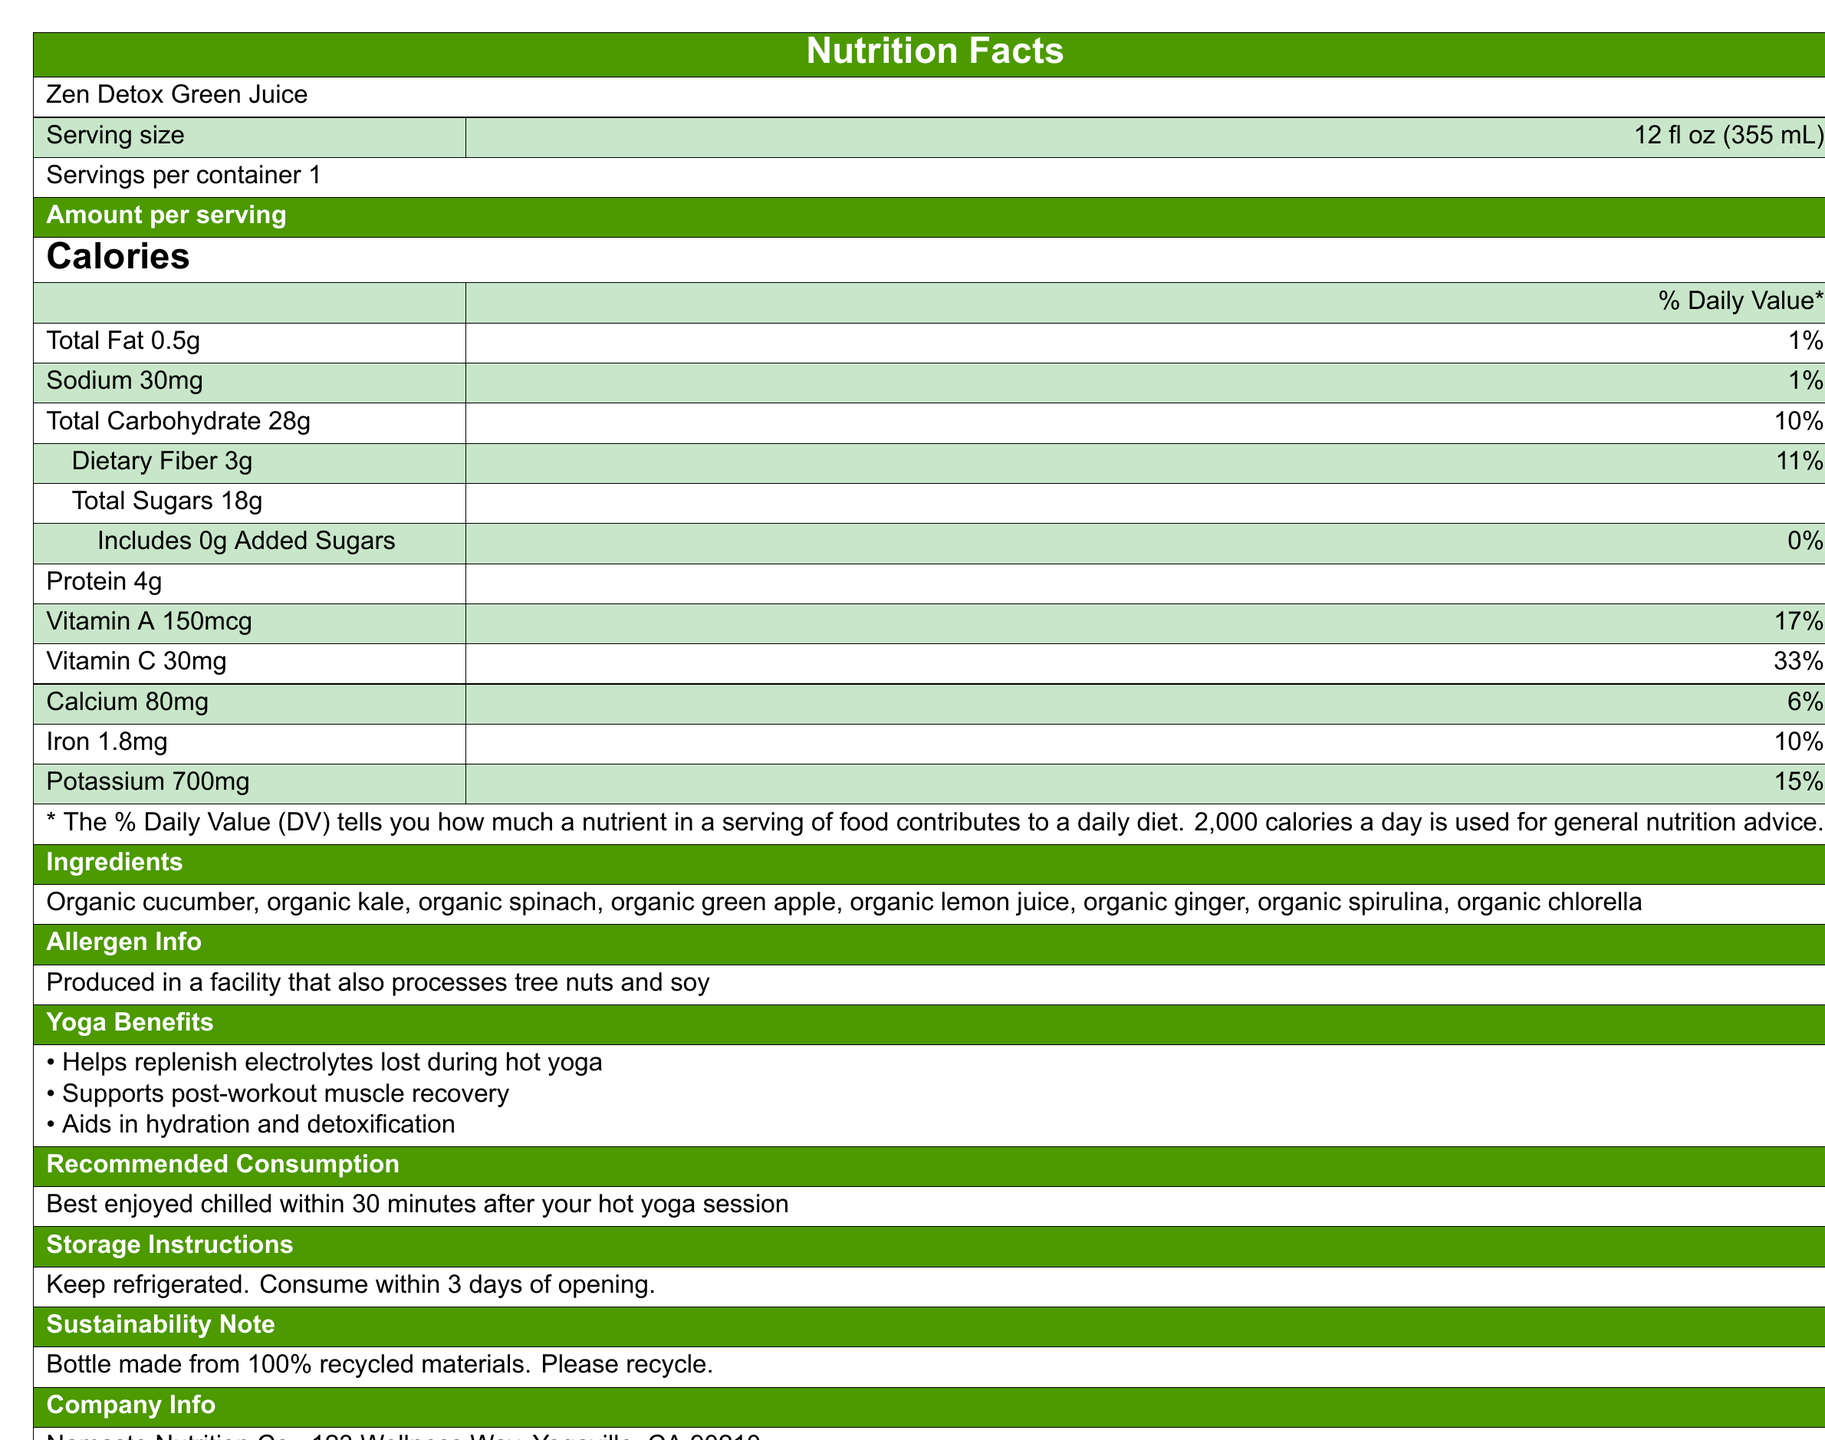what is the serving size for Zen Detox Green Juice? The document lists the serving size as "12 fl oz (355 mL)" under the product name.
Answer: 12 fl oz (355 mL) how many calories are in a serving of Zen Detox Green Juice? The number of calories per serving is prominently displayed as 120.
Answer: 120 what is the amount of dietary fiber in one serving, and its % Daily Value? The document specifies dietary fiber as 3g, which is 11% of the Daily Value.
Answer: 3g, 11% which vitamins are highlighted as being in significant amounts, and what are their % Daily Values? The vitamins provided in significant amounts are Vitamin A at 17% of the Daily Value and Vitamin C at 33%.
Answer: Vitamin A: 17%, Vitamin C: 33% what is the Total Fat content and its % Daily Value in the drink? The Total Fat content is 0.5g, which accounts for 1% of the Daily Value.
Answer: 0.5g, 1% what ingredients are included in the Zen Detox Green Juice? The ingredients are listed as organic cucumber, kale, spinach, green apple, lemon juice, ginger, spirulina, and chlorella.
Answer: Organic cucumber, Organic kale, Organic spinach, Organic green apple, Organic lemon juice, Organic ginger, Organic spirulina, Organic chlorella what is the sodium content per serving? The sodium content per serving is listed as 30mg.
Answer: 30mg what is the main claim regarding potassium content in Zen Detox Green Juice? A. Excellent source of potassium B. Good source of potassium C. Low source of potassium The health claims section mentions that Zen Detox Green Juice is a good source of potassium.
Answer: B. Good source of potassium which of the following is NOT an ingredient in Zen Detox Green Juice? A. Organic kale B. Organic green apple C. Organic carrot The ingredient list does not include organic carrot, while both organic kale and organic green apple are included.
Answer: C. Organic carrot is there any added sugar in Zen Detox Green Juice? The document states that the juice includes 0g of added sugars.
Answer: No is Zen Detox Green Juice suitable for someone with a tree nut allergy based on the allergen information provided? The allergen info reveals it is produced in a facility that also processes tree nuts, which might be problematic for someone with a tree nut allergy.
Answer: No what are the main benefits of this juice for yoga practitioners? The yoga benefits section lists these three main benefits specifically for yoga practitioners.
Answer: Helps replenish electrolytes, supports post-workout muscle recovery, aids in hydration and detoxification what is the best time to consume the juice after a hot yoga session for optimal benefits? The recommended consumption is to enjoy the juice chilled within 30 minutes after a hot yoga session.
Answer: Within 30 minutes how should the juice be stored and how long is it safe to consume after opening? The storage instructions clearly state to keep the juice refrigerated and consume it within 3 days of opening.
Answer: Keep refrigerated, consume within 3 days of opening. what sustainability practice is highlighted in the document? The document mentions that the bottle is made from 100% recycled materials and encourages recycling.
Answer: Bottle made from 100% recycled materials who is the manufacturer of Zen Detox Green Juice and where are they located? The company info states Namaste Nutrition Co. as the manufacturer located at 123 Wellness Way, Yogaville, CA 90210.
Answer: Namaste Nutrition Co., Yogaville, CA 90210 summarize the main idea of the document. The document details Zen Detox Green Juice's nutritional content, post-yoga benefits, ingredient list, storage instructions, sustainability practices, and allergen info.
Answer: The document provides detailed nutritional information about Zen Detox Green Juice, highlighting its benefits, ingredients, and storage instructions. It emphasizes the juice's suitability for post-hot yoga recovery, noting its nutritional benefits, including essential vitamins and minerals. Additionally, it includes sustainability practices and allergen information. how is the % Daily Value of protein displayed in the document? The document lists the protein content as 4g but does not provide the percentage of the Daily Value for protein.
Answer: Not provided 